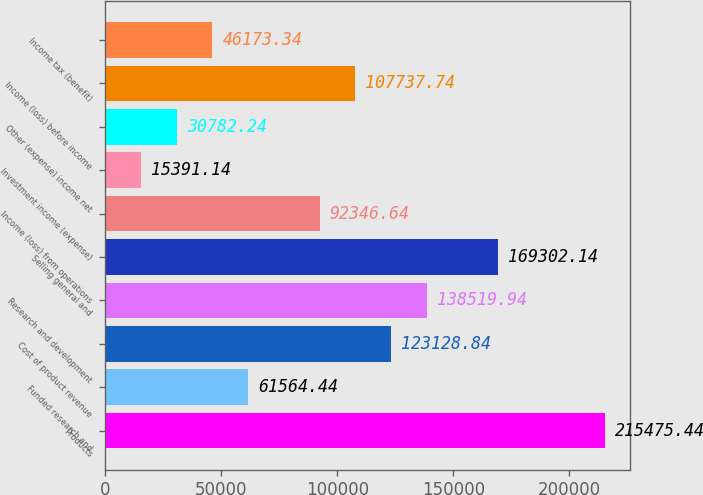<chart> <loc_0><loc_0><loc_500><loc_500><bar_chart><fcel>Products<fcel>Funded research and<fcel>Cost of product revenue<fcel>Research and development<fcel>Selling general and<fcel>Income (loss) from operations<fcel>Investment income (expense)<fcel>Other (expense) income net<fcel>Income (loss) before income<fcel>Income tax (benefit)<nl><fcel>215475<fcel>61564.4<fcel>123129<fcel>138520<fcel>169302<fcel>92346.6<fcel>15391.1<fcel>30782.2<fcel>107738<fcel>46173.3<nl></chart> 